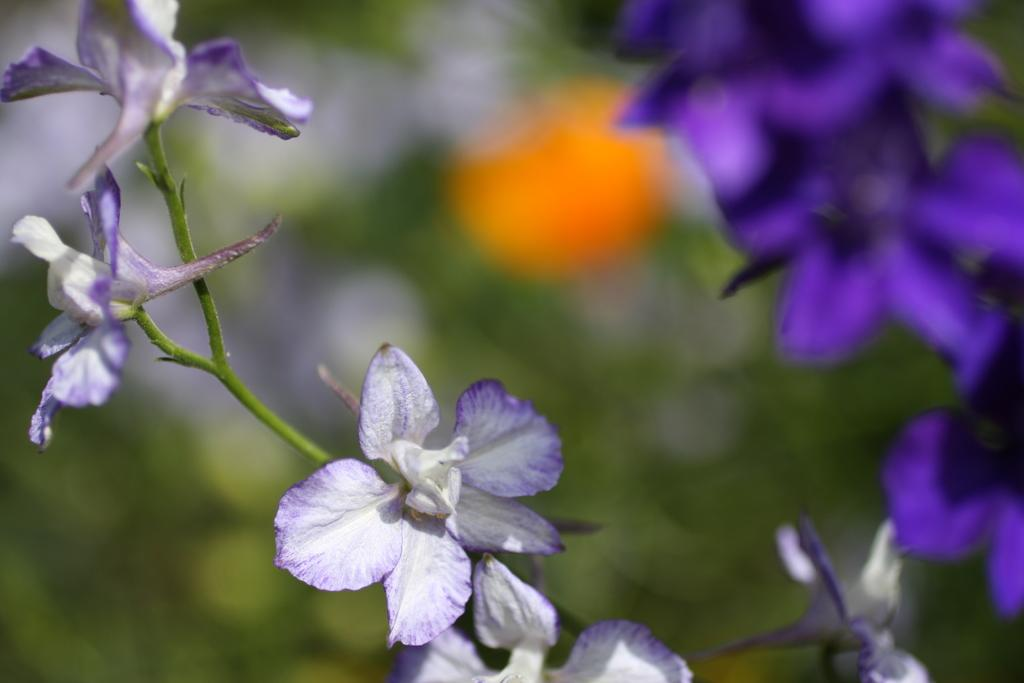What is the main subject of the image? The main subject of the image is flowers. Can you describe the flowers in the image? The flowers are white and blue in color. What can be seen in the background of the image? There are trees in the background of the image. What type of sponge is being used to water the flowers in the image? There is no sponge visible in the image, and it is not mentioned that the flowers are being watered. 